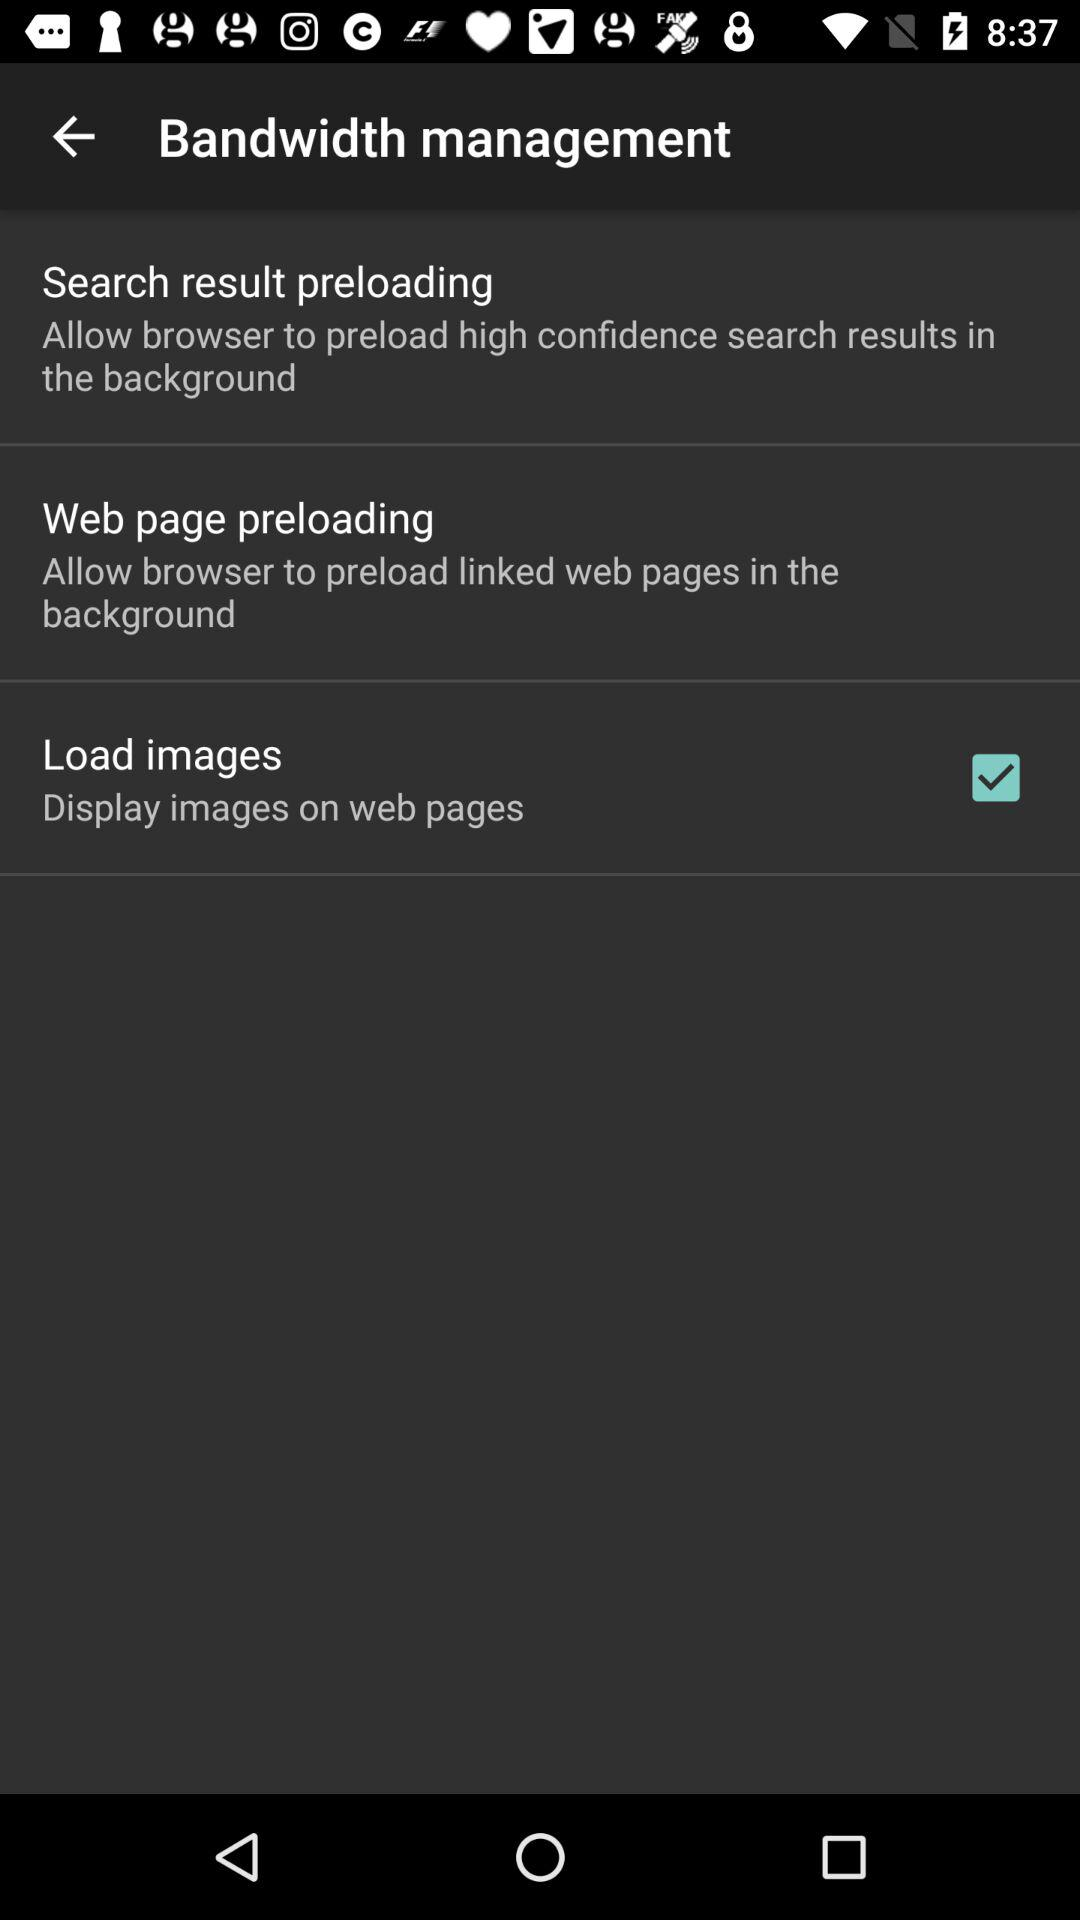What is the status of "Load images"? The status is "on". 